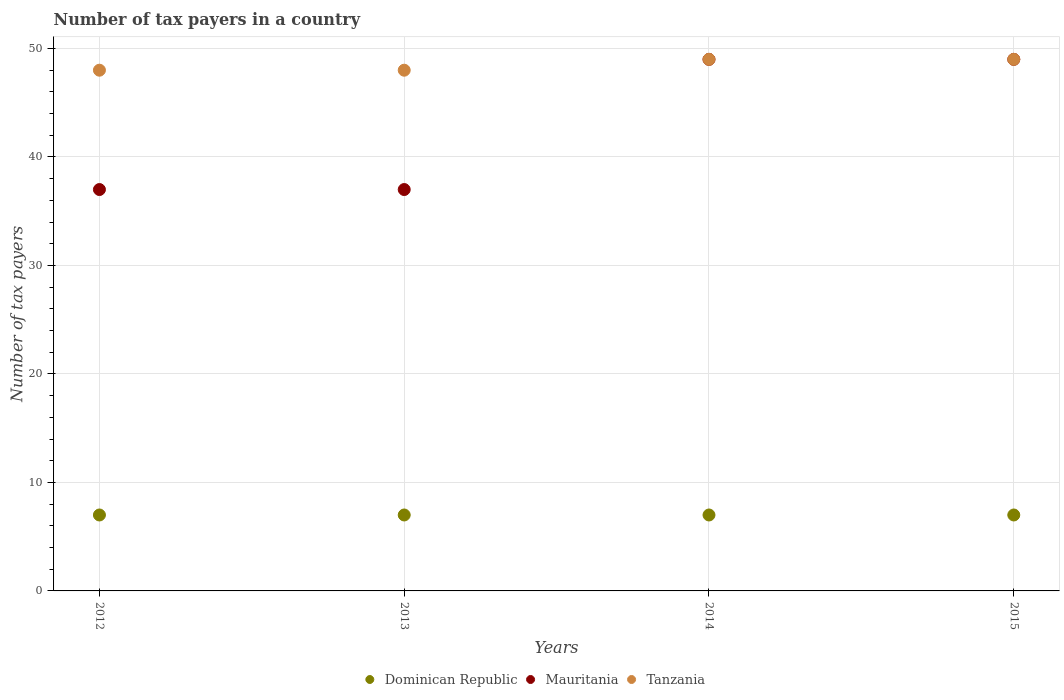How many different coloured dotlines are there?
Your answer should be very brief. 3. Is the number of dotlines equal to the number of legend labels?
Offer a terse response. Yes. What is the number of tax payers in in Dominican Republic in 2013?
Provide a short and direct response. 7. Across all years, what is the maximum number of tax payers in in Tanzania?
Your response must be concise. 49. Across all years, what is the minimum number of tax payers in in Mauritania?
Your answer should be compact. 37. What is the total number of tax payers in in Dominican Republic in the graph?
Your response must be concise. 28. What is the difference between the number of tax payers in in Mauritania in 2012 and that in 2014?
Provide a short and direct response. -12. What is the difference between the number of tax payers in in Tanzania in 2014 and the number of tax payers in in Mauritania in 2012?
Your answer should be compact. 12. What is the average number of tax payers in in Dominican Republic per year?
Make the answer very short. 7. In how many years, is the number of tax payers in in Tanzania greater than 16?
Your answer should be compact. 4. What is the ratio of the number of tax payers in in Tanzania in 2012 to that in 2015?
Your answer should be compact. 0.98. Is the number of tax payers in in Dominican Republic in 2012 less than that in 2014?
Your answer should be compact. No. Is the difference between the number of tax payers in in Tanzania in 2013 and 2014 greater than the difference between the number of tax payers in in Mauritania in 2013 and 2014?
Your response must be concise. Yes. What is the difference between the highest and the lowest number of tax payers in in Tanzania?
Give a very brief answer. 1. In how many years, is the number of tax payers in in Tanzania greater than the average number of tax payers in in Tanzania taken over all years?
Your response must be concise. 2. Does the number of tax payers in in Dominican Republic monotonically increase over the years?
Ensure brevity in your answer.  No. Is the number of tax payers in in Mauritania strictly less than the number of tax payers in in Tanzania over the years?
Ensure brevity in your answer.  No. Are the values on the major ticks of Y-axis written in scientific E-notation?
Provide a succinct answer. No. How many legend labels are there?
Ensure brevity in your answer.  3. How are the legend labels stacked?
Give a very brief answer. Horizontal. What is the title of the graph?
Your response must be concise. Number of tax payers in a country. Does "Dominica" appear as one of the legend labels in the graph?
Give a very brief answer. No. What is the label or title of the Y-axis?
Give a very brief answer. Number of tax payers. What is the Number of tax payers in Dominican Republic in 2012?
Ensure brevity in your answer.  7. What is the Number of tax payers in Mauritania in 2012?
Offer a very short reply. 37. What is the Number of tax payers of Dominican Republic in 2013?
Keep it short and to the point. 7. What is the Number of tax payers in Tanzania in 2013?
Give a very brief answer. 48. What is the Number of tax payers in Mauritania in 2015?
Your answer should be compact. 49. What is the Number of tax payers in Tanzania in 2015?
Provide a succinct answer. 49. Across all years, what is the minimum Number of tax payers of Dominican Republic?
Offer a terse response. 7. Across all years, what is the minimum Number of tax payers of Mauritania?
Keep it short and to the point. 37. Across all years, what is the minimum Number of tax payers of Tanzania?
Make the answer very short. 48. What is the total Number of tax payers in Dominican Republic in the graph?
Give a very brief answer. 28. What is the total Number of tax payers in Mauritania in the graph?
Ensure brevity in your answer.  172. What is the total Number of tax payers in Tanzania in the graph?
Give a very brief answer. 194. What is the difference between the Number of tax payers of Tanzania in 2012 and that in 2013?
Ensure brevity in your answer.  0. What is the difference between the Number of tax payers in Dominican Republic in 2012 and that in 2014?
Offer a very short reply. 0. What is the difference between the Number of tax payers in Dominican Republic in 2012 and that in 2015?
Give a very brief answer. 0. What is the difference between the Number of tax payers in Mauritania in 2012 and that in 2015?
Your answer should be very brief. -12. What is the difference between the Number of tax payers of Tanzania in 2012 and that in 2015?
Offer a terse response. -1. What is the difference between the Number of tax payers of Dominican Republic in 2013 and that in 2014?
Keep it short and to the point. 0. What is the difference between the Number of tax payers in Dominican Republic in 2013 and that in 2015?
Ensure brevity in your answer.  0. What is the difference between the Number of tax payers in Mauritania in 2013 and that in 2015?
Give a very brief answer. -12. What is the difference between the Number of tax payers in Tanzania in 2013 and that in 2015?
Ensure brevity in your answer.  -1. What is the difference between the Number of tax payers in Dominican Republic in 2014 and that in 2015?
Ensure brevity in your answer.  0. What is the difference between the Number of tax payers of Dominican Republic in 2012 and the Number of tax payers of Mauritania in 2013?
Offer a terse response. -30. What is the difference between the Number of tax payers in Dominican Republic in 2012 and the Number of tax payers in Tanzania in 2013?
Provide a succinct answer. -41. What is the difference between the Number of tax payers of Dominican Republic in 2012 and the Number of tax payers of Mauritania in 2014?
Your answer should be very brief. -42. What is the difference between the Number of tax payers in Dominican Republic in 2012 and the Number of tax payers in Tanzania in 2014?
Keep it short and to the point. -42. What is the difference between the Number of tax payers of Mauritania in 2012 and the Number of tax payers of Tanzania in 2014?
Ensure brevity in your answer.  -12. What is the difference between the Number of tax payers in Dominican Republic in 2012 and the Number of tax payers in Mauritania in 2015?
Your response must be concise. -42. What is the difference between the Number of tax payers of Dominican Republic in 2012 and the Number of tax payers of Tanzania in 2015?
Your answer should be very brief. -42. What is the difference between the Number of tax payers of Mauritania in 2012 and the Number of tax payers of Tanzania in 2015?
Provide a short and direct response. -12. What is the difference between the Number of tax payers of Dominican Republic in 2013 and the Number of tax payers of Mauritania in 2014?
Your answer should be compact. -42. What is the difference between the Number of tax payers of Dominican Republic in 2013 and the Number of tax payers of Tanzania in 2014?
Offer a terse response. -42. What is the difference between the Number of tax payers of Mauritania in 2013 and the Number of tax payers of Tanzania in 2014?
Your answer should be compact. -12. What is the difference between the Number of tax payers of Dominican Republic in 2013 and the Number of tax payers of Mauritania in 2015?
Ensure brevity in your answer.  -42. What is the difference between the Number of tax payers of Dominican Republic in 2013 and the Number of tax payers of Tanzania in 2015?
Your answer should be compact. -42. What is the difference between the Number of tax payers in Dominican Republic in 2014 and the Number of tax payers in Mauritania in 2015?
Your response must be concise. -42. What is the difference between the Number of tax payers in Dominican Republic in 2014 and the Number of tax payers in Tanzania in 2015?
Keep it short and to the point. -42. What is the average Number of tax payers of Dominican Republic per year?
Your response must be concise. 7. What is the average Number of tax payers in Mauritania per year?
Offer a terse response. 43. What is the average Number of tax payers in Tanzania per year?
Make the answer very short. 48.5. In the year 2012, what is the difference between the Number of tax payers of Dominican Republic and Number of tax payers of Mauritania?
Offer a terse response. -30. In the year 2012, what is the difference between the Number of tax payers of Dominican Republic and Number of tax payers of Tanzania?
Make the answer very short. -41. In the year 2012, what is the difference between the Number of tax payers of Mauritania and Number of tax payers of Tanzania?
Your answer should be very brief. -11. In the year 2013, what is the difference between the Number of tax payers in Dominican Republic and Number of tax payers in Tanzania?
Ensure brevity in your answer.  -41. In the year 2014, what is the difference between the Number of tax payers in Dominican Republic and Number of tax payers in Mauritania?
Keep it short and to the point. -42. In the year 2014, what is the difference between the Number of tax payers in Dominican Republic and Number of tax payers in Tanzania?
Provide a succinct answer. -42. In the year 2015, what is the difference between the Number of tax payers in Dominican Republic and Number of tax payers in Mauritania?
Make the answer very short. -42. In the year 2015, what is the difference between the Number of tax payers in Dominican Republic and Number of tax payers in Tanzania?
Your answer should be compact. -42. What is the ratio of the Number of tax payers in Dominican Republic in 2012 to that in 2013?
Make the answer very short. 1. What is the ratio of the Number of tax payers of Mauritania in 2012 to that in 2013?
Your answer should be compact. 1. What is the ratio of the Number of tax payers of Mauritania in 2012 to that in 2014?
Offer a terse response. 0.76. What is the ratio of the Number of tax payers in Tanzania in 2012 to that in 2014?
Make the answer very short. 0.98. What is the ratio of the Number of tax payers of Mauritania in 2012 to that in 2015?
Your answer should be very brief. 0.76. What is the ratio of the Number of tax payers in Tanzania in 2012 to that in 2015?
Provide a succinct answer. 0.98. What is the ratio of the Number of tax payers of Dominican Republic in 2013 to that in 2014?
Provide a succinct answer. 1. What is the ratio of the Number of tax payers in Mauritania in 2013 to that in 2014?
Provide a succinct answer. 0.76. What is the ratio of the Number of tax payers in Tanzania in 2013 to that in 2014?
Your response must be concise. 0.98. What is the ratio of the Number of tax payers of Mauritania in 2013 to that in 2015?
Offer a terse response. 0.76. What is the ratio of the Number of tax payers in Tanzania in 2013 to that in 2015?
Keep it short and to the point. 0.98. What is the ratio of the Number of tax payers of Mauritania in 2014 to that in 2015?
Provide a succinct answer. 1. What is the ratio of the Number of tax payers of Tanzania in 2014 to that in 2015?
Make the answer very short. 1. What is the difference between the highest and the second highest Number of tax payers of Dominican Republic?
Give a very brief answer. 0. What is the difference between the highest and the second highest Number of tax payers of Tanzania?
Your answer should be very brief. 0. What is the difference between the highest and the lowest Number of tax payers in Dominican Republic?
Give a very brief answer. 0. What is the difference between the highest and the lowest Number of tax payers in Mauritania?
Ensure brevity in your answer.  12. What is the difference between the highest and the lowest Number of tax payers of Tanzania?
Provide a short and direct response. 1. 